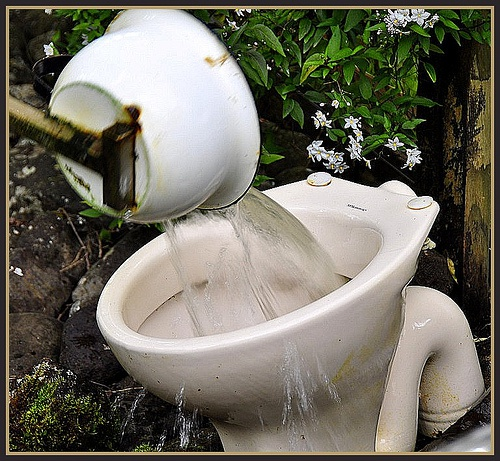Describe the objects in this image and their specific colors. I can see toilet in black, darkgray, lightgray, and gray tones and bowl in black, white, darkgray, and gray tones in this image. 